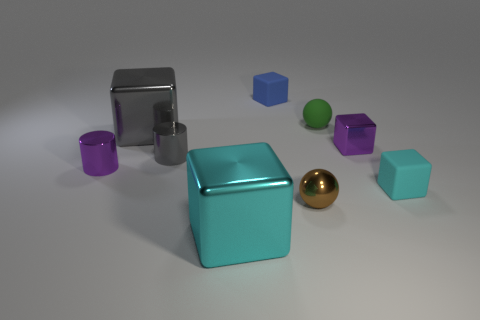What material is the tiny thing that is on the right side of the tiny gray cylinder and to the left of the tiny brown object?
Your answer should be very brief. Rubber. There is a purple object that is made of the same material as the purple block; what is its shape?
Your response must be concise. Cylinder. How many cubes are behind the tiny purple thing that is to the left of the small green rubber sphere?
Offer a very short reply. 3. How many blocks are both behind the tiny brown metallic object and on the left side of the small cyan rubber block?
Offer a very short reply. 3. How many other objects are the same material as the small gray object?
Offer a very short reply. 5. There is a cube behind the big block behind the cyan metallic cube; what is its color?
Your response must be concise. Blue. Does the cylinder that is to the left of the gray metal cylinder have the same color as the small metal cube?
Provide a short and direct response. Yes. Does the gray cube have the same size as the brown object?
Offer a very short reply. No. The green object that is the same size as the brown shiny ball is what shape?
Your answer should be very brief. Sphere. There is a matte object in front of the purple cylinder; is its size the same as the cyan metallic cube?
Give a very brief answer. No. 